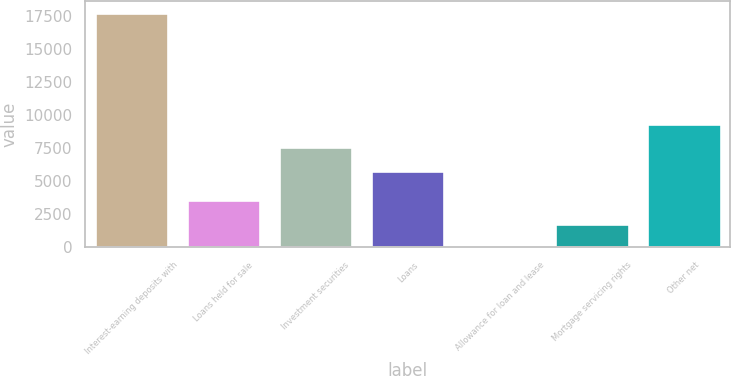Convert chart to OTSL. <chart><loc_0><loc_0><loc_500><loc_500><bar_chart><fcel>Interest-earning deposits with<fcel>Loans held for sale<fcel>Investment securities<fcel>Loans<fcel>Allowance for loan and lease<fcel>Mortgage servicing rights<fcel>Other net<nl><fcel>17702<fcel>3554.8<fcel>7555.4<fcel>5787<fcel>18<fcel>1786.4<fcel>9323.8<nl></chart> 